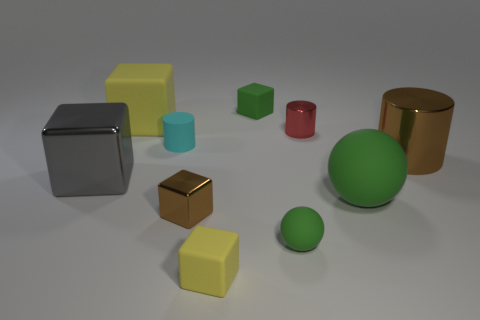How many other things are there of the same size as the gray thing?
Offer a terse response. 3. Are there any other things that are the same material as the large brown object?
Offer a terse response. Yes. What number of cylinders are to the left of the small red thing and to the right of the green cube?
Your response must be concise. 0. What color is the big shiny object left of the brown shiny thing that is on the right side of the small red object?
Provide a short and direct response. Gray. Is the number of big green spheres that are in front of the small brown shiny cube the same as the number of brown cylinders?
Your response must be concise. No. How many small cyan rubber cylinders are in front of the small matte object that is left of the yellow thing in front of the tiny sphere?
Your answer should be compact. 0. The large rubber thing right of the small yellow matte cube is what color?
Your response must be concise. Green. What is the large object that is both in front of the cyan object and left of the small red shiny object made of?
Make the answer very short. Metal. How many large yellow cubes are left of the tiny metallic thing that is behind the gray block?
Keep it short and to the point. 1. The large green object is what shape?
Offer a terse response. Sphere. 